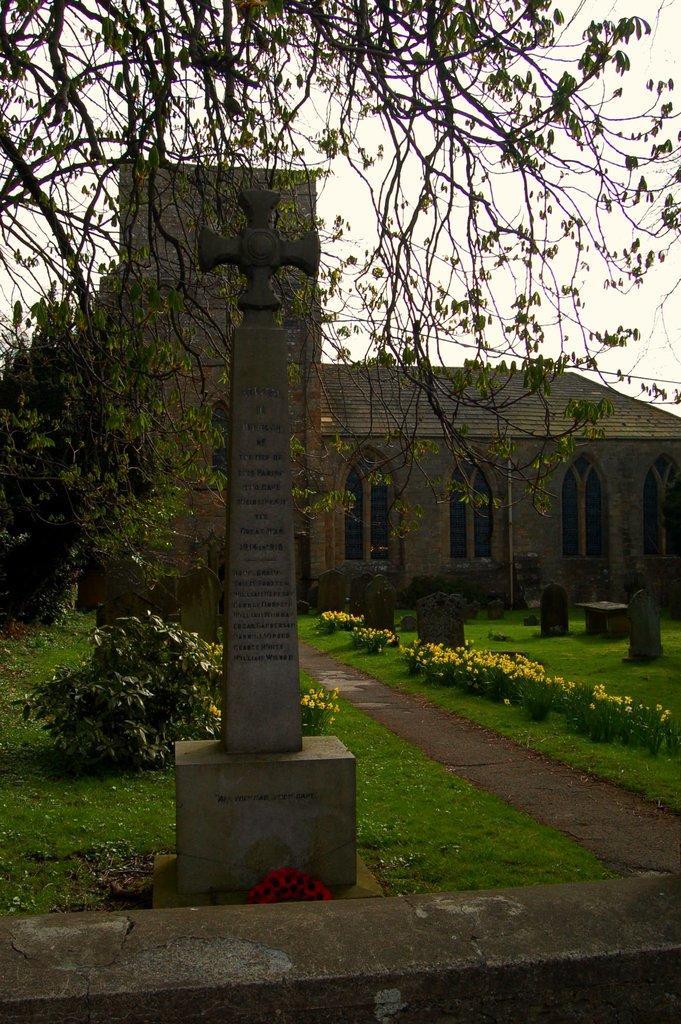Could you give a brief overview of what you see in this image? This is a memorial stone. Background there is a building with windows, tree, plants and grass. 